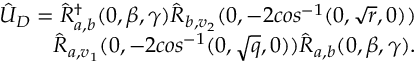Convert formula to latex. <formula><loc_0><loc_0><loc_500><loc_500>\begin{array} { r } { \hat { U } _ { D } = \hat { R } _ { a , b } ^ { \dagger } ( 0 , \beta , \gamma ) \hat { R } _ { b , v _ { 2 } } ( 0 , - 2 \cos ^ { - 1 } ( 0 , \sqrt { r } , 0 ) ) } \\ { \hat { R } _ { a , v _ { 1 } } ( 0 , - 2 \cos ^ { - 1 } ( 0 , \sqrt { q } , 0 ) ) \hat { R } _ { a , b } ( 0 , \beta , \gamma ) . } \end{array}</formula> 